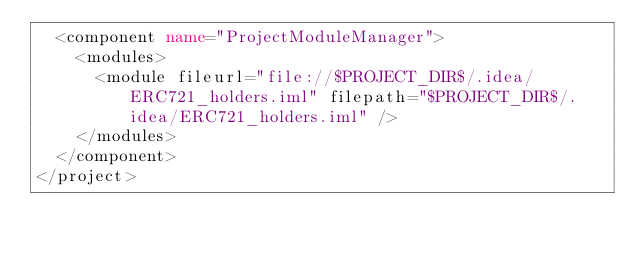Convert code to text. <code><loc_0><loc_0><loc_500><loc_500><_XML_>  <component name="ProjectModuleManager">
    <modules>
      <module fileurl="file://$PROJECT_DIR$/.idea/ERC721_holders.iml" filepath="$PROJECT_DIR$/.idea/ERC721_holders.iml" />
    </modules>
  </component>
</project></code> 